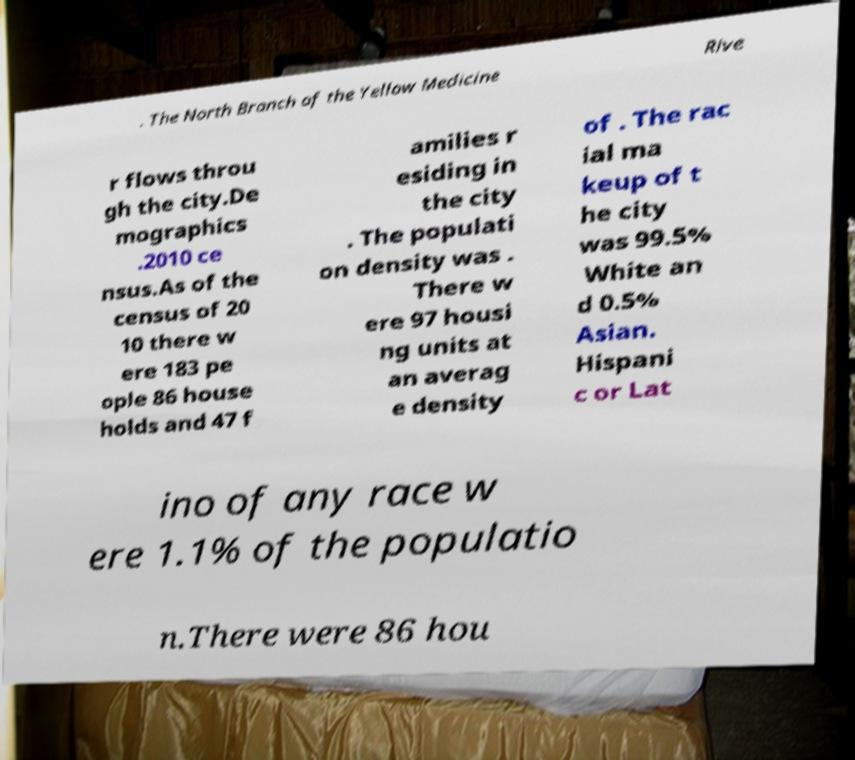What messages or text are displayed in this image? I need them in a readable, typed format. . The North Branch of the Yellow Medicine Rive r flows throu gh the city.De mographics .2010 ce nsus.As of the census of 20 10 there w ere 183 pe ople 86 house holds and 47 f amilies r esiding in the city . The populati on density was . There w ere 97 housi ng units at an averag e density of . The rac ial ma keup of t he city was 99.5% White an d 0.5% Asian. Hispani c or Lat ino of any race w ere 1.1% of the populatio n.There were 86 hou 